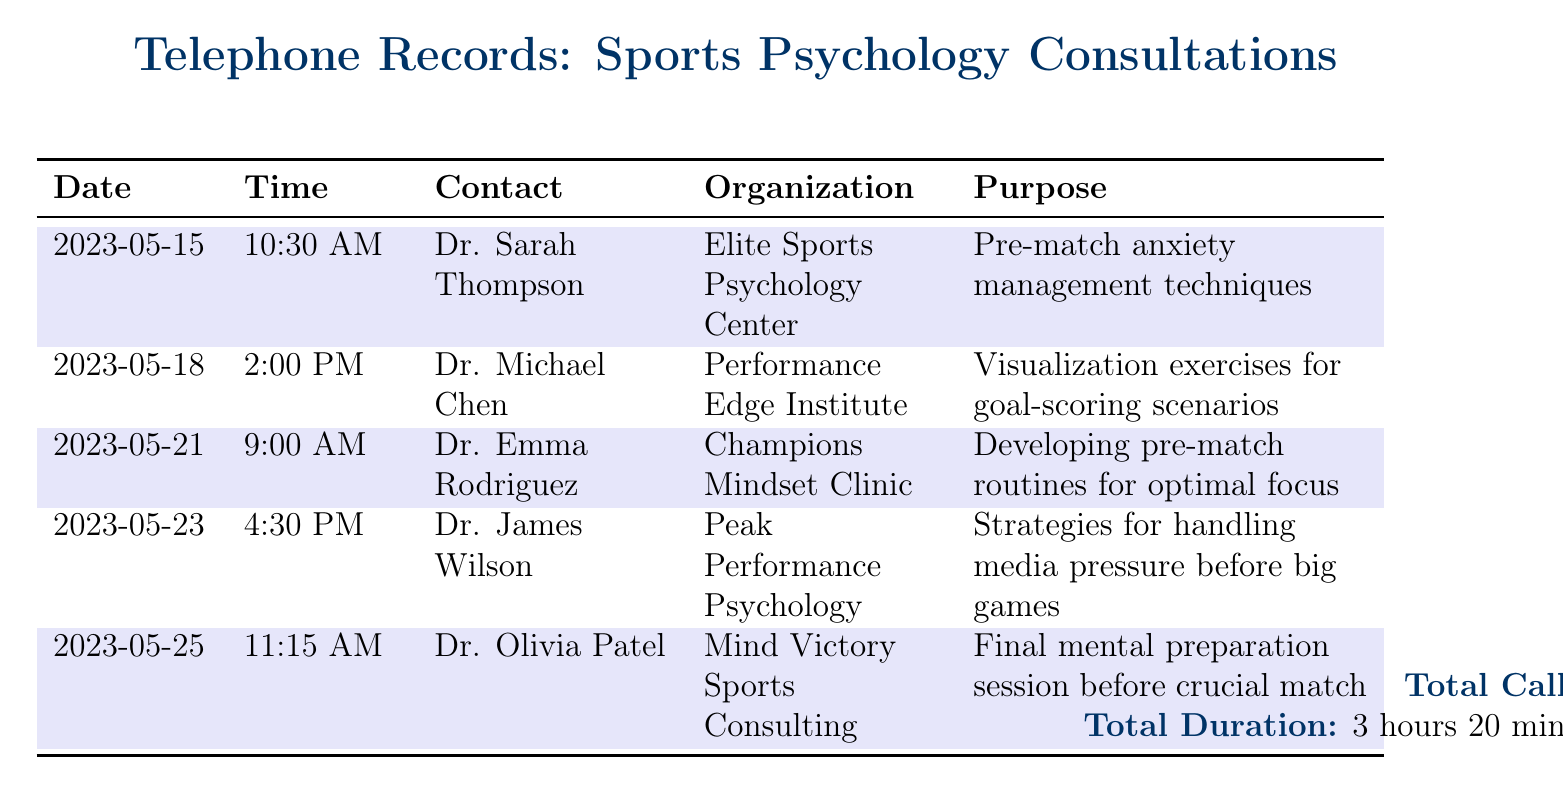What is the date of the first call? The first call is recorded on May 15, 2023.
Answer: May 15, 2023 Who is the contact for the final preparation session? The last entry shows Dr. Olivia Patel as the contact for the final preparation session.
Answer: Dr. Olivia Patel How many calls were made regarding pre-match routines? There are two calls listed specifically related to pre-match routines.
Answer: 2 What organization did Dr. Michael Chen belong to? Dr. Michael Chen is associated with the Performance Edge Institute as per the document.
Answer: Performance Edge Institute What was the purpose of the call on May 23? The call on May 23 was aimed at handling media pressure before big games.
Answer: Strategies for handling media pressure before big games What is the total duration of calls made? The document states the total duration of all calls is 3 hours and 20 minutes.
Answer: 3 hours 20 minutes How many days were there between the first and last call? The calls occurred from May 15 to May 25, totaling ten days between the first and last call.
Answer: 10 days Which psychologist focused on visualization exercises? Dr. Michael Chen focused on visualization exercises for goal-scoring scenarios.
Answer: Dr. Michael Chen 